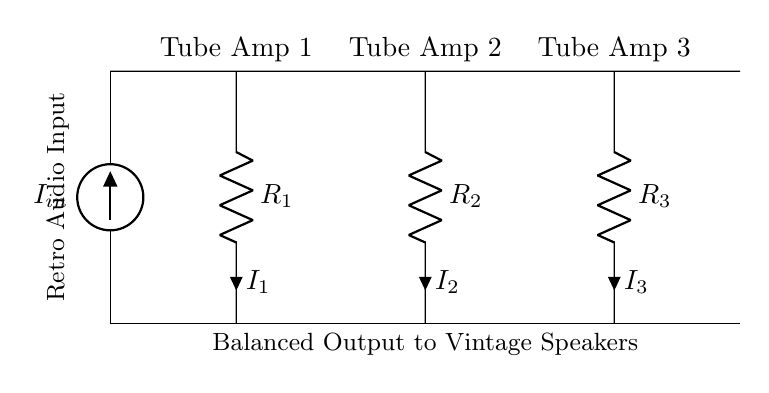What is the input current in the circuit? The circuit has an input current labeled as I_in, which represents the total current flowing into the circuit from the current source.
Answer: I_in How many resistors are in the current divider circuit? The circuit diagram clearly shows three resistors (R1, R2, and R3) connected to the input.
Answer: 3 What type of amplifiers are connected to the resistors? The diagram indicates that each resistor is connected to a "Tube Amp," confirming that these represent vintage vacuum tube amplifiers.
Answer: Tube Amps What is the current passing through R2? The current flowing through R2 is labeled as I2, indicating that this is the specific current for this resistor connected to Tube Amp 2.
Answer: I2 What happens to the total current at the output? The diagram suggests that the total current will split among the three resistors (and hence the amplifiers), which is a characteristic of current dividers, contributing to balanced output across them.
Answer: Split If R1 has a value of 100 ohms and the input current is 3 amps, what is the value of I1? Using the current divider formula, I1 can be calculated based on the total input current and the resistance values, knowing that I1, I2, and I3 depend on their respective resistances in parallel. Here, we need values of all resistors to compute; thus I1 would be derived from the ratio with respect to R1.
Answer: Depends on R2 and R3 values 